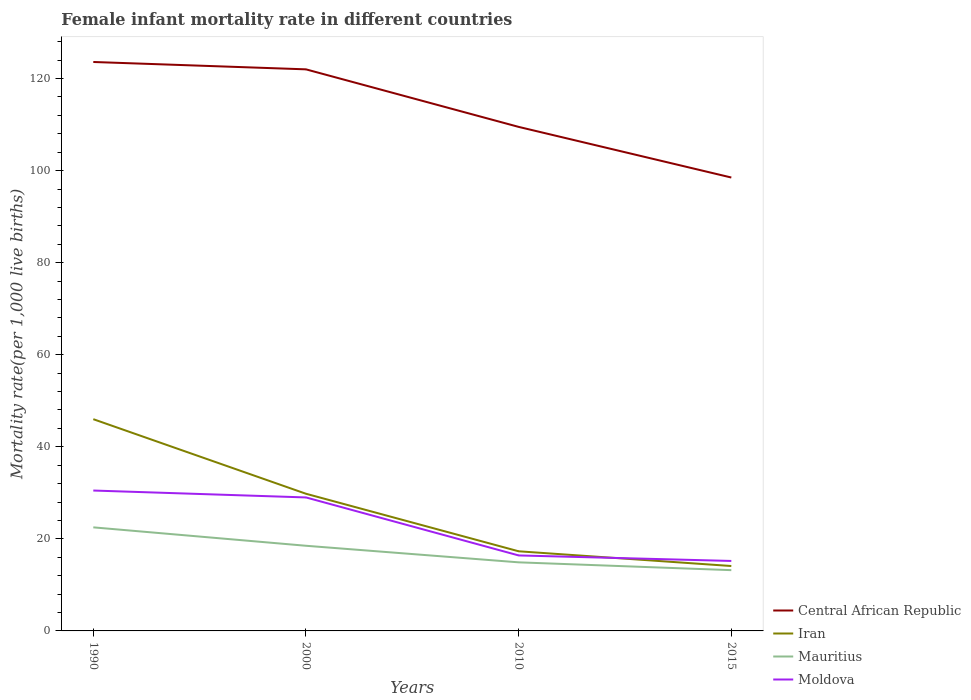How many different coloured lines are there?
Your answer should be compact. 4. In which year was the female infant mortality rate in Iran maximum?
Provide a succinct answer. 2015. What is the total female infant mortality rate in Moldova in the graph?
Your answer should be very brief. 14.1. What is the difference between the highest and the second highest female infant mortality rate in Central African Republic?
Give a very brief answer. 25.1. Is the female infant mortality rate in Iran strictly greater than the female infant mortality rate in Moldova over the years?
Make the answer very short. No. How many lines are there?
Your answer should be very brief. 4. How many years are there in the graph?
Provide a short and direct response. 4. Does the graph contain any zero values?
Ensure brevity in your answer.  No. Does the graph contain grids?
Offer a terse response. No. Where does the legend appear in the graph?
Give a very brief answer. Bottom right. What is the title of the graph?
Offer a terse response. Female infant mortality rate in different countries. Does "Equatorial Guinea" appear as one of the legend labels in the graph?
Give a very brief answer. No. What is the label or title of the X-axis?
Make the answer very short. Years. What is the label or title of the Y-axis?
Offer a terse response. Mortality rate(per 1,0 live births). What is the Mortality rate(per 1,000 live births) of Central African Republic in 1990?
Give a very brief answer. 123.6. What is the Mortality rate(per 1,000 live births) in Mauritius in 1990?
Provide a succinct answer. 22.5. What is the Mortality rate(per 1,000 live births) in Moldova in 1990?
Ensure brevity in your answer.  30.5. What is the Mortality rate(per 1,000 live births) in Central African Republic in 2000?
Keep it short and to the point. 122. What is the Mortality rate(per 1,000 live births) in Iran in 2000?
Give a very brief answer. 29.8. What is the Mortality rate(per 1,000 live births) in Moldova in 2000?
Provide a short and direct response. 29. What is the Mortality rate(per 1,000 live births) of Central African Republic in 2010?
Your answer should be compact. 109.5. What is the Mortality rate(per 1,000 live births) in Iran in 2010?
Give a very brief answer. 17.3. What is the Mortality rate(per 1,000 live births) in Central African Republic in 2015?
Keep it short and to the point. 98.5. What is the Mortality rate(per 1,000 live births) in Moldova in 2015?
Your answer should be very brief. 15.2. Across all years, what is the maximum Mortality rate(per 1,000 live births) of Central African Republic?
Your answer should be compact. 123.6. Across all years, what is the maximum Mortality rate(per 1,000 live births) in Moldova?
Your response must be concise. 30.5. Across all years, what is the minimum Mortality rate(per 1,000 live births) in Central African Republic?
Ensure brevity in your answer.  98.5. Across all years, what is the minimum Mortality rate(per 1,000 live births) in Mauritius?
Keep it short and to the point. 13.2. Across all years, what is the minimum Mortality rate(per 1,000 live births) in Moldova?
Give a very brief answer. 15.2. What is the total Mortality rate(per 1,000 live births) in Central African Republic in the graph?
Keep it short and to the point. 453.6. What is the total Mortality rate(per 1,000 live births) in Iran in the graph?
Provide a succinct answer. 107.2. What is the total Mortality rate(per 1,000 live births) of Mauritius in the graph?
Your response must be concise. 69.1. What is the total Mortality rate(per 1,000 live births) of Moldova in the graph?
Offer a very short reply. 91.1. What is the difference between the Mortality rate(per 1,000 live births) of Central African Republic in 1990 and that in 2000?
Your response must be concise. 1.6. What is the difference between the Mortality rate(per 1,000 live births) in Moldova in 1990 and that in 2000?
Provide a short and direct response. 1.5. What is the difference between the Mortality rate(per 1,000 live births) of Central African Republic in 1990 and that in 2010?
Keep it short and to the point. 14.1. What is the difference between the Mortality rate(per 1,000 live births) of Iran in 1990 and that in 2010?
Offer a very short reply. 28.7. What is the difference between the Mortality rate(per 1,000 live births) in Mauritius in 1990 and that in 2010?
Offer a very short reply. 7.6. What is the difference between the Mortality rate(per 1,000 live births) in Moldova in 1990 and that in 2010?
Keep it short and to the point. 14.1. What is the difference between the Mortality rate(per 1,000 live births) of Central African Republic in 1990 and that in 2015?
Provide a short and direct response. 25.1. What is the difference between the Mortality rate(per 1,000 live births) of Iran in 1990 and that in 2015?
Offer a terse response. 31.9. What is the difference between the Mortality rate(per 1,000 live births) of Mauritius in 1990 and that in 2015?
Provide a short and direct response. 9.3. What is the difference between the Mortality rate(per 1,000 live births) of Central African Republic in 2000 and that in 2010?
Your response must be concise. 12.5. What is the difference between the Mortality rate(per 1,000 live births) of Mauritius in 2000 and that in 2010?
Ensure brevity in your answer.  3.6. What is the difference between the Mortality rate(per 1,000 live births) of Iran in 2000 and that in 2015?
Give a very brief answer. 15.7. What is the difference between the Mortality rate(per 1,000 live births) in Mauritius in 2000 and that in 2015?
Give a very brief answer. 5.3. What is the difference between the Mortality rate(per 1,000 live births) in Moldova in 2000 and that in 2015?
Provide a succinct answer. 13.8. What is the difference between the Mortality rate(per 1,000 live births) in Iran in 2010 and that in 2015?
Provide a short and direct response. 3.2. What is the difference between the Mortality rate(per 1,000 live births) of Mauritius in 2010 and that in 2015?
Give a very brief answer. 1.7. What is the difference between the Mortality rate(per 1,000 live births) in Moldova in 2010 and that in 2015?
Ensure brevity in your answer.  1.2. What is the difference between the Mortality rate(per 1,000 live births) in Central African Republic in 1990 and the Mortality rate(per 1,000 live births) in Iran in 2000?
Your response must be concise. 93.8. What is the difference between the Mortality rate(per 1,000 live births) of Central African Republic in 1990 and the Mortality rate(per 1,000 live births) of Mauritius in 2000?
Your response must be concise. 105.1. What is the difference between the Mortality rate(per 1,000 live births) of Central African Republic in 1990 and the Mortality rate(per 1,000 live births) of Moldova in 2000?
Your answer should be compact. 94.6. What is the difference between the Mortality rate(per 1,000 live births) in Mauritius in 1990 and the Mortality rate(per 1,000 live births) in Moldova in 2000?
Offer a terse response. -6.5. What is the difference between the Mortality rate(per 1,000 live births) in Central African Republic in 1990 and the Mortality rate(per 1,000 live births) in Iran in 2010?
Your answer should be very brief. 106.3. What is the difference between the Mortality rate(per 1,000 live births) of Central African Republic in 1990 and the Mortality rate(per 1,000 live births) of Mauritius in 2010?
Provide a succinct answer. 108.7. What is the difference between the Mortality rate(per 1,000 live births) of Central African Republic in 1990 and the Mortality rate(per 1,000 live births) of Moldova in 2010?
Provide a short and direct response. 107.2. What is the difference between the Mortality rate(per 1,000 live births) of Iran in 1990 and the Mortality rate(per 1,000 live births) of Mauritius in 2010?
Your response must be concise. 31.1. What is the difference between the Mortality rate(per 1,000 live births) in Iran in 1990 and the Mortality rate(per 1,000 live births) in Moldova in 2010?
Your answer should be very brief. 29.6. What is the difference between the Mortality rate(per 1,000 live births) of Central African Republic in 1990 and the Mortality rate(per 1,000 live births) of Iran in 2015?
Offer a very short reply. 109.5. What is the difference between the Mortality rate(per 1,000 live births) in Central African Republic in 1990 and the Mortality rate(per 1,000 live births) in Mauritius in 2015?
Provide a short and direct response. 110.4. What is the difference between the Mortality rate(per 1,000 live births) of Central African Republic in 1990 and the Mortality rate(per 1,000 live births) of Moldova in 2015?
Offer a very short reply. 108.4. What is the difference between the Mortality rate(per 1,000 live births) in Iran in 1990 and the Mortality rate(per 1,000 live births) in Mauritius in 2015?
Make the answer very short. 32.8. What is the difference between the Mortality rate(per 1,000 live births) in Iran in 1990 and the Mortality rate(per 1,000 live births) in Moldova in 2015?
Offer a very short reply. 30.8. What is the difference between the Mortality rate(per 1,000 live births) of Central African Republic in 2000 and the Mortality rate(per 1,000 live births) of Iran in 2010?
Your answer should be very brief. 104.7. What is the difference between the Mortality rate(per 1,000 live births) in Central African Republic in 2000 and the Mortality rate(per 1,000 live births) in Mauritius in 2010?
Provide a short and direct response. 107.1. What is the difference between the Mortality rate(per 1,000 live births) in Central African Republic in 2000 and the Mortality rate(per 1,000 live births) in Moldova in 2010?
Offer a very short reply. 105.6. What is the difference between the Mortality rate(per 1,000 live births) of Iran in 2000 and the Mortality rate(per 1,000 live births) of Moldova in 2010?
Ensure brevity in your answer.  13.4. What is the difference between the Mortality rate(per 1,000 live births) in Central African Republic in 2000 and the Mortality rate(per 1,000 live births) in Iran in 2015?
Make the answer very short. 107.9. What is the difference between the Mortality rate(per 1,000 live births) of Central African Republic in 2000 and the Mortality rate(per 1,000 live births) of Mauritius in 2015?
Give a very brief answer. 108.8. What is the difference between the Mortality rate(per 1,000 live births) in Central African Republic in 2000 and the Mortality rate(per 1,000 live births) in Moldova in 2015?
Make the answer very short. 106.8. What is the difference between the Mortality rate(per 1,000 live births) in Iran in 2000 and the Mortality rate(per 1,000 live births) in Moldova in 2015?
Give a very brief answer. 14.6. What is the difference between the Mortality rate(per 1,000 live births) in Mauritius in 2000 and the Mortality rate(per 1,000 live births) in Moldova in 2015?
Your answer should be compact. 3.3. What is the difference between the Mortality rate(per 1,000 live births) in Central African Republic in 2010 and the Mortality rate(per 1,000 live births) in Iran in 2015?
Offer a very short reply. 95.4. What is the difference between the Mortality rate(per 1,000 live births) of Central African Republic in 2010 and the Mortality rate(per 1,000 live births) of Mauritius in 2015?
Give a very brief answer. 96.3. What is the difference between the Mortality rate(per 1,000 live births) in Central African Republic in 2010 and the Mortality rate(per 1,000 live births) in Moldova in 2015?
Offer a very short reply. 94.3. What is the difference between the Mortality rate(per 1,000 live births) in Mauritius in 2010 and the Mortality rate(per 1,000 live births) in Moldova in 2015?
Make the answer very short. -0.3. What is the average Mortality rate(per 1,000 live births) in Central African Republic per year?
Offer a terse response. 113.4. What is the average Mortality rate(per 1,000 live births) in Iran per year?
Offer a terse response. 26.8. What is the average Mortality rate(per 1,000 live births) of Mauritius per year?
Provide a short and direct response. 17.27. What is the average Mortality rate(per 1,000 live births) of Moldova per year?
Ensure brevity in your answer.  22.77. In the year 1990, what is the difference between the Mortality rate(per 1,000 live births) in Central African Republic and Mortality rate(per 1,000 live births) in Iran?
Keep it short and to the point. 77.6. In the year 1990, what is the difference between the Mortality rate(per 1,000 live births) of Central African Republic and Mortality rate(per 1,000 live births) of Mauritius?
Ensure brevity in your answer.  101.1. In the year 1990, what is the difference between the Mortality rate(per 1,000 live births) of Central African Republic and Mortality rate(per 1,000 live births) of Moldova?
Offer a very short reply. 93.1. In the year 1990, what is the difference between the Mortality rate(per 1,000 live births) in Iran and Mortality rate(per 1,000 live births) in Moldova?
Offer a terse response. 15.5. In the year 2000, what is the difference between the Mortality rate(per 1,000 live births) of Central African Republic and Mortality rate(per 1,000 live births) of Iran?
Your answer should be compact. 92.2. In the year 2000, what is the difference between the Mortality rate(per 1,000 live births) of Central African Republic and Mortality rate(per 1,000 live births) of Mauritius?
Your answer should be very brief. 103.5. In the year 2000, what is the difference between the Mortality rate(per 1,000 live births) of Central African Republic and Mortality rate(per 1,000 live births) of Moldova?
Your response must be concise. 93. In the year 2010, what is the difference between the Mortality rate(per 1,000 live births) of Central African Republic and Mortality rate(per 1,000 live births) of Iran?
Your answer should be compact. 92.2. In the year 2010, what is the difference between the Mortality rate(per 1,000 live births) in Central African Republic and Mortality rate(per 1,000 live births) in Mauritius?
Ensure brevity in your answer.  94.6. In the year 2010, what is the difference between the Mortality rate(per 1,000 live births) in Central African Republic and Mortality rate(per 1,000 live births) in Moldova?
Ensure brevity in your answer.  93.1. In the year 2010, what is the difference between the Mortality rate(per 1,000 live births) of Iran and Mortality rate(per 1,000 live births) of Moldova?
Your response must be concise. 0.9. In the year 2010, what is the difference between the Mortality rate(per 1,000 live births) in Mauritius and Mortality rate(per 1,000 live births) in Moldova?
Offer a terse response. -1.5. In the year 2015, what is the difference between the Mortality rate(per 1,000 live births) of Central African Republic and Mortality rate(per 1,000 live births) of Iran?
Offer a very short reply. 84.4. In the year 2015, what is the difference between the Mortality rate(per 1,000 live births) of Central African Republic and Mortality rate(per 1,000 live births) of Mauritius?
Ensure brevity in your answer.  85.3. In the year 2015, what is the difference between the Mortality rate(per 1,000 live births) in Central African Republic and Mortality rate(per 1,000 live births) in Moldova?
Provide a short and direct response. 83.3. In the year 2015, what is the difference between the Mortality rate(per 1,000 live births) in Iran and Mortality rate(per 1,000 live births) in Mauritius?
Provide a succinct answer. 0.9. In the year 2015, what is the difference between the Mortality rate(per 1,000 live births) of Iran and Mortality rate(per 1,000 live births) of Moldova?
Offer a terse response. -1.1. What is the ratio of the Mortality rate(per 1,000 live births) of Central African Republic in 1990 to that in 2000?
Keep it short and to the point. 1.01. What is the ratio of the Mortality rate(per 1,000 live births) in Iran in 1990 to that in 2000?
Make the answer very short. 1.54. What is the ratio of the Mortality rate(per 1,000 live births) in Mauritius in 1990 to that in 2000?
Make the answer very short. 1.22. What is the ratio of the Mortality rate(per 1,000 live births) in Moldova in 1990 to that in 2000?
Your answer should be very brief. 1.05. What is the ratio of the Mortality rate(per 1,000 live births) of Central African Republic in 1990 to that in 2010?
Offer a very short reply. 1.13. What is the ratio of the Mortality rate(per 1,000 live births) of Iran in 1990 to that in 2010?
Keep it short and to the point. 2.66. What is the ratio of the Mortality rate(per 1,000 live births) of Mauritius in 1990 to that in 2010?
Ensure brevity in your answer.  1.51. What is the ratio of the Mortality rate(per 1,000 live births) of Moldova in 1990 to that in 2010?
Your answer should be compact. 1.86. What is the ratio of the Mortality rate(per 1,000 live births) in Central African Republic in 1990 to that in 2015?
Offer a very short reply. 1.25. What is the ratio of the Mortality rate(per 1,000 live births) of Iran in 1990 to that in 2015?
Your answer should be compact. 3.26. What is the ratio of the Mortality rate(per 1,000 live births) of Mauritius in 1990 to that in 2015?
Provide a succinct answer. 1.7. What is the ratio of the Mortality rate(per 1,000 live births) in Moldova in 1990 to that in 2015?
Make the answer very short. 2.01. What is the ratio of the Mortality rate(per 1,000 live births) of Central African Republic in 2000 to that in 2010?
Provide a short and direct response. 1.11. What is the ratio of the Mortality rate(per 1,000 live births) in Iran in 2000 to that in 2010?
Your response must be concise. 1.72. What is the ratio of the Mortality rate(per 1,000 live births) of Mauritius in 2000 to that in 2010?
Provide a short and direct response. 1.24. What is the ratio of the Mortality rate(per 1,000 live births) of Moldova in 2000 to that in 2010?
Offer a terse response. 1.77. What is the ratio of the Mortality rate(per 1,000 live births) of Central African Republic in 2000 to that in 2015?
Provide a short and direct response. 1.24. What is the ratio of the Mortality rate(per 1,000 live births) in Iran in 2000 to that in 2015?
Your answer should be very brief. 2.11. What is the ratio of the Mortality rate(per 1,000 live births) of Mauritius in 2000 to that in 2015?
Ensure brevity in your answer.  1.4. What is the ratio of the Mortality rate(per 1,000 live births) in Moldova in 2000 to that in 2015?
Ensure brevity in your answer.  1.91. What is the ratio of the Mortality rate(per 1,000 live births) in Central African Republic in 2010 to that in 2015?
Ensure brevity in your answer.  1.11. What is the ratio of the Mortality rate(per 1,000 live births) of Iran in 2010 to that in 2015?
Your response must be concise. 1.23. What is the ratio of the Mortality rate(per 1,000 live births) of Mauritius in 2010 to that in 2015?
Offer a terse response. 1.13. What is the ratio of the Mortality rate(per 1,000 live births) in Moldova in 2010 to that in 2015?
Provide a short and direct response. 1.08. What is the difference between the highest and the second highest Mortality rate(per 1,000 live births) of Central African Republic?
Ensure brevity in your answer.  1.6. What is the difference between the highest and the second highest Mortality rate(per 1,000 live births) in Iran?
Offer a very short reply. 16.2. What is the difference between the highest and the lowest Mortality rate(per 1,000 live births) of Central African Republic?
Offer a terse response. 25.1. What is the difference between the highest and the lowest Mortality rate(per 1,000 live births) in Iran?
Your answer should be compact. 31.9. What is the difference between the highest and the lowest Mortality rate(per 1,000 live births) of Moldova?
Provide a short and direct response. 15.3. 